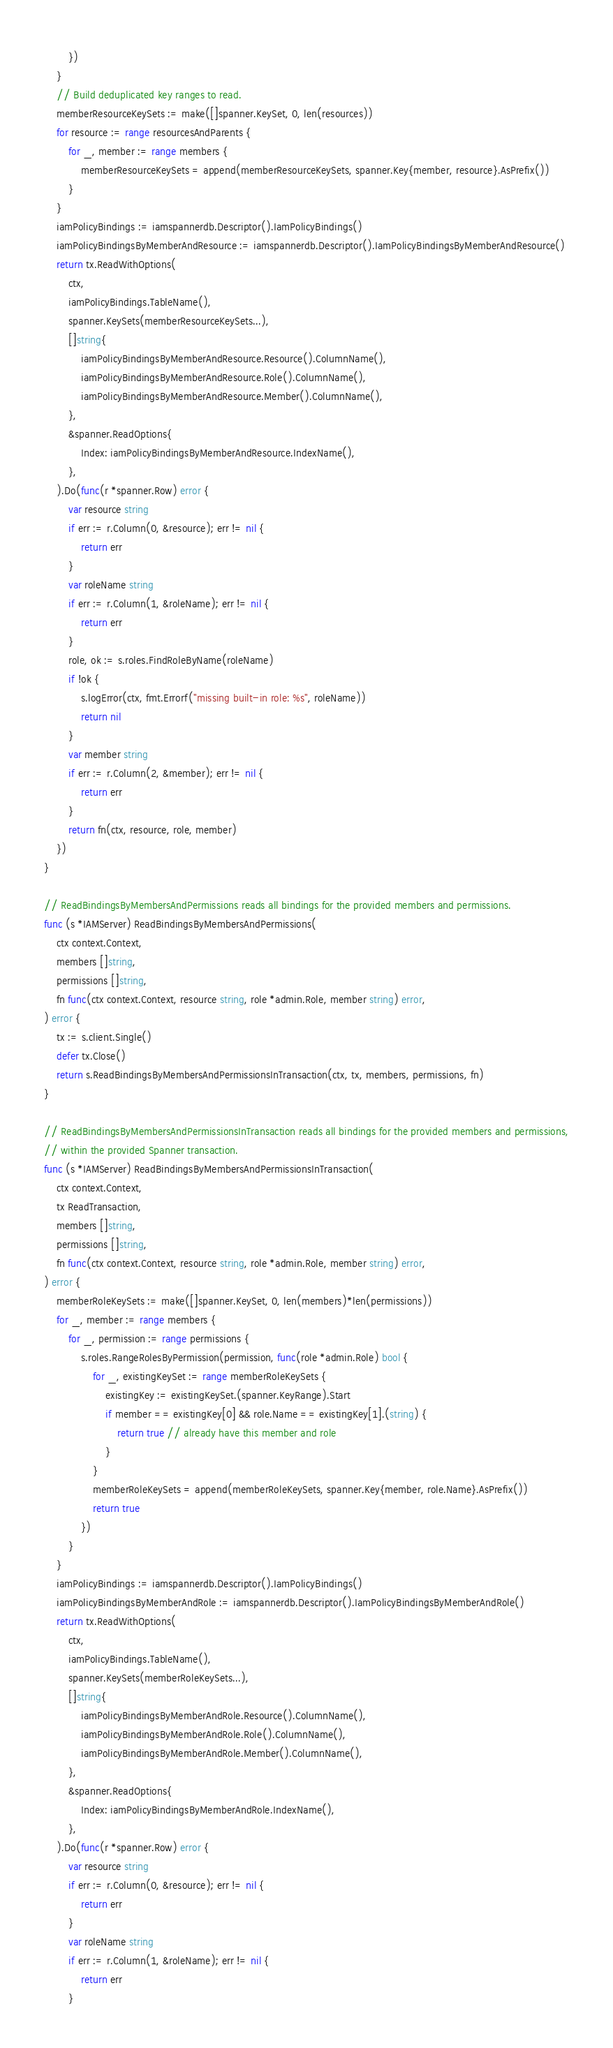<code> <loc_0><loc_0><loc_500><loc_500><_Go_>		})
	}
	// Build deduplicated key ranges to read.
	memberResourceKeySets := make([]spanner.KeySet, 0, len(resources))
	for resource := range resourcesAndParents {
		for _, member := range members {
			memberResourceKeySets = append(memberResourceKeySets, spanner.Key{member, resource}.AsPrefix())
		}
	}
	iamPolicyBindings := iamspannerdb.Descriptor().IamPolicyBindings()
	iamPolicyBindingsByMemberAndResource := iamspannerdb.Descriptor().IamPolicyBindingsByMemberAndResource()
	return tx.ReadWithOptions(
		ctx,
		iamPolicyBindings.TableName(),
		spanner.KeySets(memberResourceKeySets...),
		[]string{
			iamPolicyBindingsByMemberAndResource.Resource().ColumnName(),
			iamPolicyBindingsByMemberAndResource.Role().ColumnName(),
			iamPolicyBindingsByMemberAndResource.Member().ColumnName(),
		},
		&spanner.ReadOptions{
			Index: iamPolicyBindingsByMemberAndResource.IndexName(),
		},
	).Do(func(r *spanner.Row) error {
		var resource string
		if err := r.Column(0, &resource); err != nil {
			return err
		}
		var roleName string
		if err := r.Column(1, &roleName); err != nil {
			return err
		}
		role, ok := s.roles.FindRoleByName(roleName)
		if !ok {
			s.logError(ctx, fmt.Errorf("missing built-in role: %s", roleName))
			return nil
		}
		var member string
		if err := r.Column(2, &member); err != nil {
			return err
		}
		return fn(ctx, resource, role, member)
	})
}

// ReadBindingsByMembersAndPermissions reads all bindings for the provided members and permissions.
func (s *IAMServer) ReadBindingsByMembersAndPermissions(
	ctx context.Context,
	members []string,
	permissions []string,
	fn func(ctx context.Context, resource string, role *admin.Role, member string) error,
) error {
	tx := s.client.Single()
	defer tx.Close()
	return s.ReadBindingsByMembersAndPermissionsInTransaction(ctx, tx, members, permissions, fn)
}

// ReadBindingsByMembersAndPermissionsInTransaction reads all bindings for the provided members and permissions,
// within the provided Spanner transaction.
func (s *IAMServer) ReadBindingsByMembersAndPermissionsInTransaction(
	ctx context.Context,
	tx ReadTransaction,
	members []string,
	permissions []string,
	fn func(ctx context.Context, resource string, role *admin.Role, member string) error,
) error {
	memberRoleKeySets := make([]spanner.KeySet, 0, len(members)*len(permissions))
	for _, member := range members {
		for _, permission := range permissions {
			s.roles.RangeRolesByPermission(permission, func(role *admin.Role) bool {
				for _, existingKeySet := range memberRoleKeySets {
					existingKey := existingKeySet.(spanner.KeyRange).Start
					if member == existingKey[0] && role.Name == existingKey[1].(string) {
						return true // already have this member and role
					}
				}
				memberRoleKeySets = append(memberRoleKeySets, spanner.Key{member, role.Name}.AsPrefix())
				return true
			})
		}
	}
	iamPolicyBindings := iamspannerdb.Descriptor().IamPolicyBindings()
	iamPolicyBindingsByMemberAndRole := iamspannerdb.Descriptor().IamPolicyBindingsByMemberAndRole()
	return tx.ReadWithOptions(
		ctx,
		iamPolicyBindings.TableName(),
		spanner.KeySets(memberRoleKeySets...),
		[]string{
			iamPolicyBindingsByMemberAndRole.Resource().ColumnName(),
			iamPolicyBindingsByMemberAndRole.Role().ColumnName(),
			iamPolicyBindingsByMemberAndRole.Member().ColumnName(),
		},
		&spanner.ReadOptions{
			Index: iamPolicyBindingsByMemberAndRole.IndexName(),
		},
	).Do(func(r *spanner.Row) error {
		var resource string
		if err := r.Column(0, &resource); err != nil {
			return err
		}
		var roleName string
		if err := r.Column(1, &roleName); err != nil {
			return err
		}</code> 